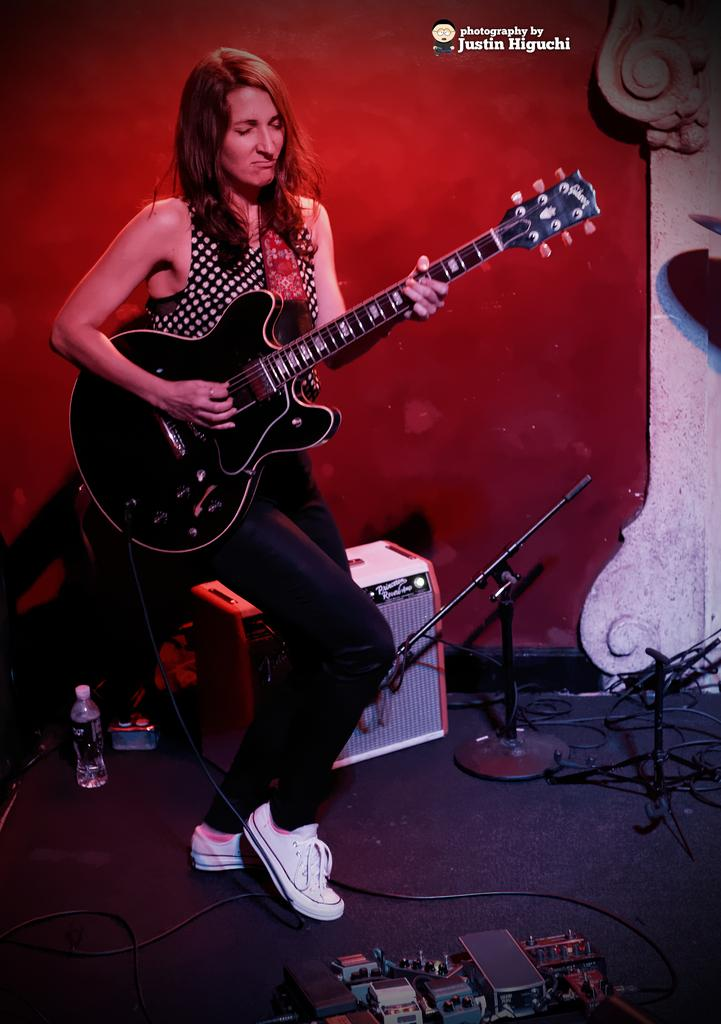Where is the setting of the image? The image is inside a room. Who is present in the image? There is a woman in the image. What is the woman doing in the image? The woman is standing and playing a guitar. What can be seen in the background of the image? There is a speaker in the background of the image. What objects are present at the bottom of the image? There are bottles, wires, and devices at the bottom of the image. Can you see any cows grazing near the lake in the image? There is no lake or cows present in the image; it is set inside a room with a woman playing a guitar. 